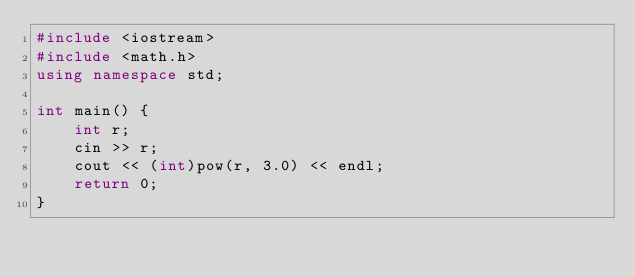<code> <loc_0><loc_0><loc_500><loc_500><_C++_>#include <iostream>
#include <math.h>
using namespace std;

int main() {
    int r;
    cin >> r;
    cout << (int)pow(r, 3.0) << endl;
    return 0;
}
</code> 